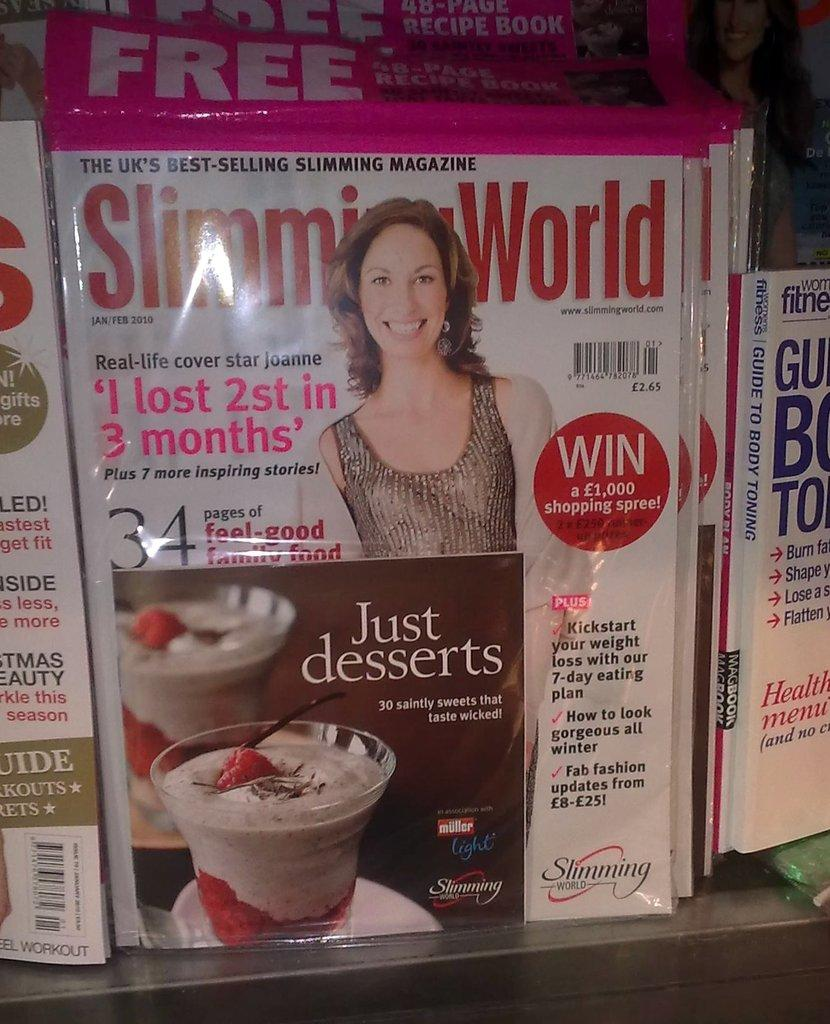<image>
Give a short and clear explanation of the subsequent image. A magazine titled Slimming World sitting behind an ad for Just Desserts. 